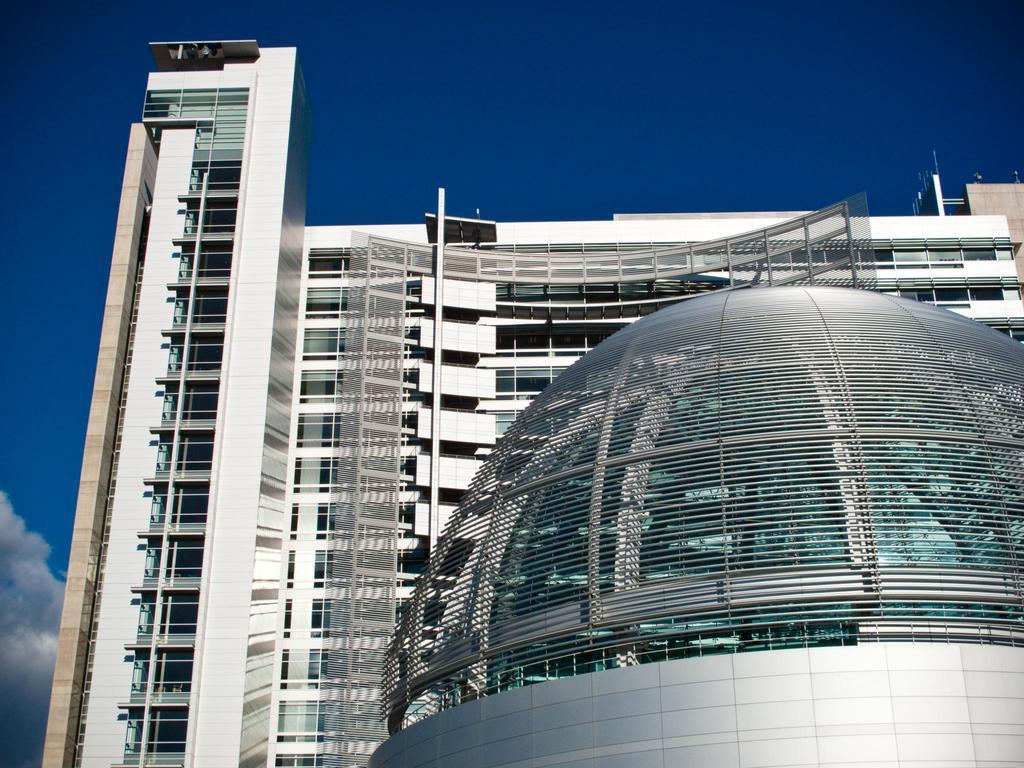What type of structure can be seen in the image? There is a building with windows in the image. Can you describe another building in the image? There is another building with a dome shape in the image. What can be seen in the background of the image? The sky is visible in the background of the image. What is present in the sky? Clouds are present in the sky. What type of leather can be seen on the actor's board in the image? There is no actor, leather, or board present in the image. 